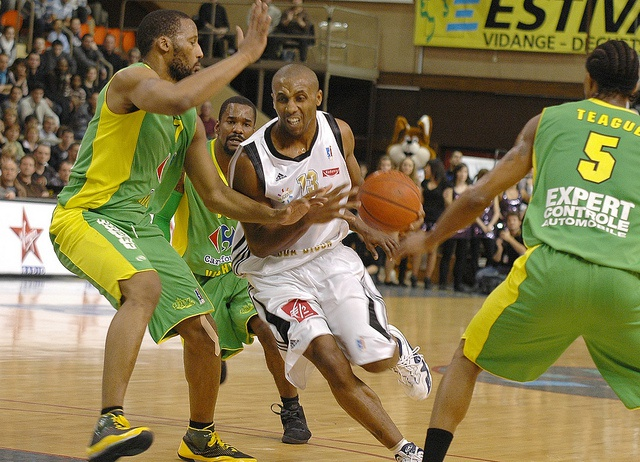Describe the objects in this image and their specific colors. I can see people in darkgreen, olive, tan, green, and gray tones, people in darkgreen, olive, green, and black tones, people in darkgreen, lightgray, darkgray, gray, and maroon tones, people in darkgreen, black, and gray tones, and people in darkgreen, maroon, and black tones in this image. 